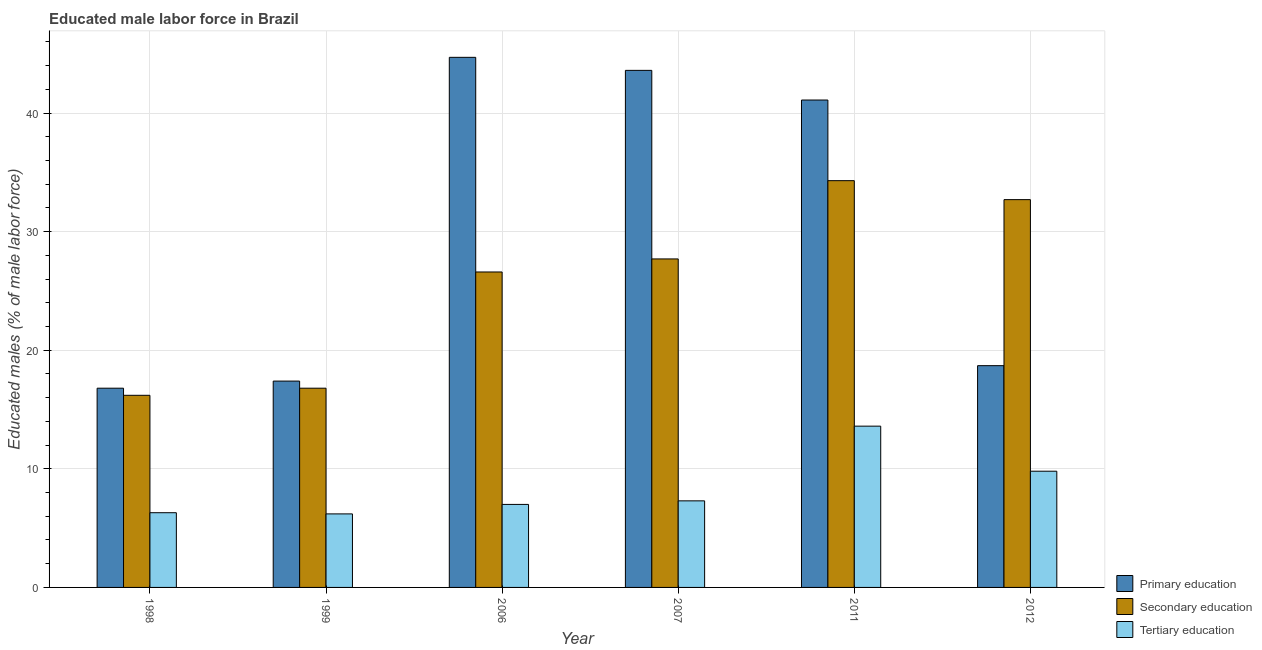How many groups of bars are there?
Your answer should be very brief. 6. How many bars are there on the 2nd tick from the left?
Keep it short and to the point. 3. In how many cases, is the number of bars for a given year not equal to the number of legend labels?
Your answer should be very brief. 0. What is the percentage of male labor force who received primary education in 2007?
Provide a succinct answer. 43.6. Across all years, what is the maximum percentage of male labor force who received tertiary education?
Offer a very short reply. 13.6. Across all years, what is the minimum percentage of male labor force who received tertiary education?
Ensure brevity in your answer.  6.2. What is the total percentage of male labor force who received tertiary education in the graph?
Offer a very short reply. 50.2. What is the difference between the percentage of male labor force who received primary education in 2006 and that in 2007?
Your response must be concise. 1.1. What is the difference between the percentage of male labor force who received tertiary education in 1999 and the percentage of male labor force who received secondary education in 2011?
Provide a succinct answer. -7.4. What is the average percentage of male labor force who received primary education per year?
Make the answer very short. 30.38. In the year 2007, what is the difference between the percentage of male labor force who received primary education and percentage of male labor force who received tertiary education?
Ensure brevity in your answer.  0. What is the ratio of the percentage of male labor force who received primary education in 2011 to that in 2012?
Keep it short and to the point. 2.2. What is the difference between the highest and the second highest percentage of male labor force who received secondary education?
Your response must be concise. 1.6. What is the difference between the highest and the lowest percentage of male labor force who received primary education?
Provide a succinct answer. 27.9. Is the sum of the percentage of male labor force who received primary education in 2011 and 2012 greater than the maximum percentage of male labor force who received tertiary education across all years?
Your answer should be very brief. Yes. What does the 1st bar from the right in 2006 represents?
Ensure brevity in your answer.  Tertiary education. Is it the case that in every year, the sum of the percentage of male labor force who received primary education and percentage of male labor force who received secondary education is greater than the percentage of male labor force who received tertiary education?
Offer a terse response. Yes. How many bars are there?
Offer a very short reply. 18. How many years are there in the graph?
Ensure brevity in your answer.  6. Are the values on the major ticks of Y-axis written in scientific E-notation?
Your answer should be compact. No. Does the graph contain any zero values?
Provide a succinct answer. No. Does the graph contain grids?
Give a very brief answer. Yes. Where does the legend appear in the graph?
Give a very brief answer. Bottom right. How many legend labels are there?
Keep it short and to the point. 3. How are the legend labels stacked?
Offer a very short reply. Vertical. What is the title of the graph?
Your answer should be very brief. Educated male labor force in Brazil. Does "Ages 60+" appear as one of the legend labels in the graph?
Ensure brevity in your answer.  No. What is the label or title of the Y-axis?
Keep it short and to the point. Educated males (% of male labor force). What is the Educated males (% of male labor force) in Primary education in 1998?
Ensure brevity in your answer.  16.8. What is the Educated males (% of male labor force) in Secondary education in 1998?
Give a very brief answer. 16.2. What is the Educated males (% of male labor force) of Tertiary education in 1998?
Your response must be concise. 6.3. What is the Educated males (% of male labor force) in Primary education in 1999?
Give a very brief answer. 17.4. What is the Educated males (% of male labor force) of Secondary education in 1999?
Give a very brief answer. 16.8. What is the Educated males (% of male labor force) of Tertiary education in 1999?
Provide a succinct answer. 6.2. What is the Educated males (% of male labor force) in Primary education in 2006?
Ensure brevity in your answer.  44.7. What is the Educated males (% of male labor force) of Secondary education in 2006?
Give a very brief answer. 26.6. What is the Educated males (% of male labor force) of Tertiary education in 2006?
Ensure brevity in your answer.  7. What is the Educated males (% of male labor force) of Primary education in 2007?
Your answer should be very brief. 43.6. What is the Educated males (% of male labor force) of Secondary education in 2007?
Ensure brevity in your answer.  27.7. What is the Educated males (% of male labor force) of Tertiary education in 2007?
Your answer should be very brief. 7.3. What is the Educated males (% of male labor force) in Primary education in 2011?
Your answer should be compact. 41.1. What is the Educated males (% of male labor force) in Secondary education in 2011?
Offer a very short reply. 34.3. What is the Educated males (% of male labor force) in Tertiary education in 2011?
Ensure brevity in your answer.  13.6. What is the Educated males (% of male labor force) in Primary education in 2012?
Ensure brevity in your answer.  18.7. What is the Educated males (% of male labor force) of Secondary education in 2012?
Ensure brevity in your answer.  32.7. What is the Educated males (% of male labor force) of Tertiary education in 2012?
Give a very brief answer. 9.8. Across all years, what is the maximum Educated males (% of male labor force) in Primary education?
Provide a succinct answer. 44.7. Across all years, what is the maximum Educated males (% of male labor force) of Secondary education?
Give a very brief answer. 34.3. Across all years, what is the maximum Educated males (% of male labor force) of Tertiary education?
Offer a terse response. 13.6. Across all years, what is the minimum Educated males (% of male labor force) in Primary education?
Offer a very short reply. 16.8. Across all years, what is the minimum Educated males (% of male labor force) in Secondary education?
Offer a very short reply. 16.2. Across all years, what is the minimum Educated males (% of male labor force) in Tertiary education?
Provide a short and direct response. 6.2. What is the total Educated males (% of male labor force) in Primary education in the graph?
Ensure brevity in your answer.  182.3. What is the total Educated males (% of male labor force) of Secondary education in the graph?
Ensure brevity in your answer.  154.3. What is the total Educated males (% of male labor force) of Tertiary education in the graph?
Offer a terse response. 50.2. What is the difference between the Educated males (% of male labor force) of Tertiary education in 1998 and that in 1999?
Provide a short and direct response. 0.1. What is the difference between the Educated males (% of male labor force) of Primary education in 1998 and that in 2006?
Keep it short and to the point. -27.9. What is the difference between the Educated males (% of male labor force) of Secondary education in 1998 and that in 2006?
Offer a very short reply. -10.4. What is the difference between the Educated males (% of male labor force) in Tertiary education in 1998 and that in 2006?
Your answer should be compact. -0.7. What is the difference between the Educated males (% of male labor force) of Primary education in 1998 and that in 2007?
Your answer should be very brief. -26.8. What is the difference between the Educated males (% of male labor force) in Primary education in 1998 and that in 2011?
Your response must be concise. -24.3. What is the difference between the Educated males (% of male labor force) of Secondary education in 1998 and that in 2011?
Make the answer very short. -18.1. What is the difference between the Educated males (% of male labor force) in Secondary education in 1998 and that in 2012?
Offer a terse response. -16.5. What is the difference between the Educated males (% of male labor force) in Tertiary education in 1998 and that in 2012?
Keep it short and to the point. -3.5. What is the difference between the Educated males (% of male labor force) in Primary education in 1999 and that in 2006?
Offer a very short reply. -27.3. What is the difference between the Educated males (% of male labor force) of Secondary education in 1999 and that in 2006?
Your response must be concise. -9.8. What is the difference between the Educated males (% of male labor force) of Tertiary education in 1999 and that in 2006?
Make the answer very short. -0.8. What is the difference between the Educated males (% of male labor force) in Primary education in 1999 and that in 2007?
Your answer should be compact. -26.2. What is the difference between the Educated males (% of male labor force) in Secondary education in 1999 and that in 2007?
Ensure brevity in your answer.  -10.9. What is the difference between the Educated males (% of male labor force) in Primary education in 1999 and that in 2011?
Your answer should be very brief. -23.7. What is the difference between the Educated males (% of male labor force) of Secondary education in 1999 and that in 2011?
Ensure brevity in your answer.  -17.5. What is the difference between the Educated males (% of male labor force) of Secondary education in 1999 and that in 2012?
Provide a short and direct response. -15.9. What is the difference between the Educated males (% of male labor force) of Tertiary education in 1999 and that in 2012?
Provide a succinct answer. -3.6. What is the difference between the Educated males (% of male labor force) in Primary education in 2006 and that in 2007?
Offer a very short reply. 1.1. What is the difference between the Educated males (% of male labor force) of Primary education in 2006 and that in 2011?
Your response must be concise. 3.6. What is the difference between the Educated males (% of male labor force) in Secondary education in 2006 and that in 2011?
Your answer should be compact. -7.7. What is the difference between the Educated males (% of male labor force) in Secondary education in 2007 and that in 2011?
Provide a short and direct response. -6.6. What is the difference between the Educated males (% of male labor force) of Tertiary education in 2007 and that in 2011?
Give a very brief answer. -6.3. What is the difference between the Educated males (% of male labor force) of Primary education in 2007 and that in 2012?
Ensure brevity in your answer.  24.9. What is the difference between the Educated males (% of male labor force) in Tertiary education in 2007 and that in 2012?
Your answer should be compact. -2.5. What is the difference between the Educated males (% of male labor force) in Primary education in 2011 and that in 2012?
Provide a short and direct response. 22.4. What is the difference between the Educated males (% of male labor force) in Tertiary education in 2011 and that in 2012?
Provide a short and direct response. 3.8. What is the difference between the Educated males (% of male labor force) of Primary education in 1998 and the Educated males (% of male labor force) of Secondary education in 1999?
Give a very brief answer. 0. What is the difference between the Educated males (% of male labor force) of Primary education in 1998 and the Educated males (% of male labor force) of Tertiary education in 1999?
Provide a succinct answer. 10.6. What is the difference between the Educated males (% of male labor force) in Primary education in 1998 and the Educated males (% of male labor force) in Tertiary education in 2006?
Offer a terse response. 9.8. What is the difference between the Educated males (% of male labor force) of Primary education in 1998 and the Educated males (% of male labor force) of Secondary education in 2007?
Offer a very short reply. -10.9. What is the difference between the Educated males (% of male labor force) of Primary education in 1998 and the Educated males (% of male labor force) of Tertiary education in 2007?
Keep it short and to the point. 9.5. What is the difference between the Educated males (% of male labor force) in Primary education in 1998 and the Educated males (% of male labor force) in Secondary education in 2011?
Offer a terse response. -17.5. What is the difference between the Educated males (% of male labor force) in Primary education in 1998 and the Educated males (% of male labor force) in Tertiary education in 2011?
Provide a short and direct response. 3.2. What is the difference between the Educated males (% of male labor force) in Primary education in 1998 and the Educated males (% of male labor force) in Secondary education in 2012?
Make the answer very short. -15.9. What is the difference between the Educated males (% of male labor force) of Primary education in 1998 and the Educated males (% of male labor force) of Tertiary education in 2012?
Ensure brevity in your answer.  7. What is the difference between the Educated males (% of male labor force) of Secondary education in 1998 and the Educated males (% of male labor force) of Tertiary education in 2012?
Ensure brevity in your answer.  6.4. What is the difference between the Educated males (% of male labor force) of Primary education in 1999 and the Educated males (% of male labor force) of Secondary education in 2006?
Keep it short and to the point. -9.2. What is the difference between the Educated males (% of male labor force) of Primary education in 1999 and the Educated males (% of male labor force) of Tertiary education in 2006?
Provide a succinct answer. 10.4. What is the difference between the Educated males (% of male labor force) of Secondary education in 1999 and the Educated males (% of male labor force) of Tertiary education in 2006?
Make the answer very short. 9.8. What is the difference between the Educated males (% of male labor force) in Primary education in 1999 and the Educated males (% of male labor force) in Tertiary education in 2007?
Your response must be concise. 10.1. What is the difference between the Educated males (% of male labor force) in Secondary education in 1999 and the Educated males (% of male labor force) in Tertiary education in 2007?
Give a very brief answer. 9.5. What is the difference between the Educated males (% of male labor force) in Primary education in 1999 and the Educated males (% of male labor force) in Secondary education in 2011?
Provide a short and direct response. -16.9. What is the difference between the Educated males (% of male labor force) in Primary education in 1999 and the Educated males (% of male labor force) in Tertiary education in 2011?
Offer a very short reply. 3.8. What is the difference between the Educated males (% of male labor force) in Primary education in 1999 and the Educated males (% of male labor force) in Secondary education in 2012?
Provide a succinct answer. -15.3. What is the difference between the Educated males (% of male labor force) in Secondary education in 1999 and the Educated males (% of male labor force) in Tertiary education in 2012?
Offer a very short reply. 7. What is the difference between the Educated males (% of male labor force) of Primary education in 2006 and the Educated males (% of male labor force) of Tertiary education in 2007?
Offer a terse response. 37.4. What is the difference between the Educated males (% of male labor force) of Secondary education in 2006 and the Educated males (% of male labor force) of Tertiary education in 2007?
Your answer should be compact. 19.3. What is the difference between the Educated males (% of male labor force) of Primary education in 2006 and the Educated males (% of male labor force) of Secondary education in 2011?
Ensure brevity in your answer.  10.4. What is the difference between the Educated males (% of male labor force) in Primary education in 2006 and the Educated males (% of male labor force) in Tertiary education in 2011?
Make the answer very short. 31.1. What is the difference between the Educated males (% of male labor force) of Secondary education in 2006 and the Educated males (% of male labor force) of Tertiary education in 2011?
Make the answer very short. 13. What is the difference between the Educated males (% of male labor force) in Primary education in 2006 and the Educated males (% of male labor force) in Secondary education in 2012?
Provide a succinct answer. 12. What is the difference between the Educated males (% of male labor force) of Primary education in 2006 and the Educated males (% of male labor force) of Tertiary education in 2012?
Your answer should be very brief. 34.9. What is the difference between the Educated males (% of male labor force) in Secondary education in 2006 and the Educated males (% of male labor force) in Tertiary education in 2012?
Provide a succinct answer. 16.8. What is the difference between the Educated males (% of male labor force) of Secondary education in 2007 and the Educated males (% of male labor force) of Tertiary education in 2011?
Offer a very short reply. 14.1. What is the difference between the Educated males (% of male labor force) of Primary education in 2007 and the Educated males (% of male labor force) of Secondary education in 2012?
Your response must be concise. 10.9. What is the difference between the Educated males (% of male labor force) of Primary education in 2007 and the Educated males (% of male labor force) of Tertiary education in 2012?
Your answer should be very brief. 33.8. What is the difference between the Educated males (% of male labor force) of Primary education in 2011 and the Educated males (% of male labor force) of Tertiary education in 2012?
Offer a very short reply. 31.3. What is the average Educated males (% of male labor force) in Primary education per year?
Your response must be concise. 30.38. What is the average Educated males (% of male labor force) in Secondary education per year?
Your response must be concise. 25.72. What is the average Educated males (% of male labor force) in Tertiary education per year?
Keep it short and to the point. 8.37. In the year 1999, what is the difference between the Educated males (% of male labor force) of Primary education and Educated males (% of male labor force) of Tertiary education?
Make the answer very short. 11.2. In the year 2006, what is the difference between the Educated males (% of male labor force) in Primary education and Educated males (% of male labor force) in Tertiary education?
Make the answer very short. 37.7. In the year 2006, what is the difference between the Educated males (% of male labor force) of Secondary education and Educated males (% of male labor force) of Tertiary education?
Provide a succinct answer. 19.6. In the year 2007, what is the difference between the Educated males (% of male labor force) in Primary education and Educated males (% of male labor force) in Tertiary education?
Give a very brief answer. 36.3. In the year 2007, what is the difference between the Educated males (% of male labor force) of Secondary education and Educated males (% of male labor force) of Tertiary education?
Your response must be concise. 20.4. In the year 2011, what is the difference between the Educated males (% of male labor force) of Secondary education and Educated males (% of male labor force) of Tertiary education?
Give a very brief answer. 20.7. In the year 2012, what is the difference between the Educated males (% of male labor force) in Primary education and Educated males (% of male labor force) in Secondary education?
Ensure brevity in your answer.  -14. In the year 2012, what is the difference between the Educated males (% of male labor force) of Secondary education and Educated males (% of male labor force) of Tertiary education?
Provide a succinct answer. 22.9. What is the ratio of the Educated males (% of male labor force) in Primary education in 1998 to that in 1999?
Your response must be concise. 0.97. What is the ratio of the Educated males (% of male labor force) in Secondary education in 1998 to that in 1999?
Provide a short and direct response. 0.96. What is the ratio of the Educated males (% of male labor force) in Tertiary education in 1998 to that in 1999?
Keep it short and to the point. 1.02. What is the ratio of the Educated males (% of male labor force) of Primary education in 1998 to that in 2006?
Give a very brief answer. 0.38. What is the ratio of the Educated males (% of male labor force) in Secondary education in 1998 to that in 2006?
Offer a very short reply. 0.61. What is the ratio of the Educated males (% of male labor force) in Tertiary education in 1998 to that in 2006?
Provide a short and direct response. 0.9. What is the ratio of the Educated males (% of male labor force) in Primary education in 1998 to that in 2007?
Offer a very short reply. 0.39. What is the ratio of the Educated males (% of male labor force) of Secondary education in 1998 to that in 2007?
Give a very brief answer. 0.58. What is the ratio of the Educated males (% of male labor force) in Tertiary education in 1998 to that in 2007?
Provide a short and direct response. 0.86. What is the ratio of the Educated males (% of male labor force) of Primary education in 1998 to that in 2011?
Ensure brevity in your answer.  0.41. What is the ratio of the Educated males (% of male labor force) of Secondary education in 1998 to that in 2011?
Make the answer very short. 0.47. What is the ratio of the Educated males (% of male labor force) in Tertiary education in 1998 to that in 2011?
Your answer should be very brief. 0.46. What is the ratio of the Educated males (% of male labor force) in Primary education in 1998 to that in 2012?
Offer a very short reply. 0.9. What is the ratio of the Educated males (% of male labor force) in Secondary education in 1998 to that in 2012?
Make the answer very short. 0.5. What is the ratio of the Educated males (% of male labor force) in Tertiary education in 1998 to that in 2012?
Offer a terse response. 0.64. What is the ratio of the Educated males (% of male labor force) of Primary education in 1999 to that in 2006?
Provide a short and direct response. 0.39. What is the ratio of the Educated males (% of male labor force) in Secondary education in 1999 to that in 2006?
Your response must be concise. 0.63. What is the ratio of the Educated males (% of male labor force) in Tertiary education in 1999 to that in 2006?
Make the answer very short. 0.89. What is the ratio of the Educated males (% of male labor force) in Primary education in 1999 to that in 2007?
Offer a terse response. 0.4. What is the ratio of the Educated males (% of male labor force) of Secondary education in 1999 to that in 2007?
Keep it short and to the point. 0.61. What is the ratio of the Educated males (% of male labor force) of Tertiary education in 1999 to that in 2007?
Give a very brief answer. 0.85. What is the ratio of the Educated males (% of male labor force) of Primary education in 1999 to that in 2011?
Provide a short and direct response. 0.42. What is the ratio of the Educated males (% of male labor force) of Secondary education in 1999 to that in 2011?
Make the answer very short. 0.49. What is the ratio of the Educated males (% of male labor force) in Tertiary education in 1999 to that in 2011?
Your answer should be compact. 0.46. What is the ratio of the Educated males (% of male labor force) in Primary education in 1999 to that in 2012?
Ensure brevity in your answer.  0.93. What is the ratio of the Educated males (% of male labor force) in Secondary education in 1999 to that in 2012?
Provide a short and direct response. 0.51. What is the ratio of the Educated males (% of male labor force) of Tertiary education in 1999 to that in 2012?
Ensure brevity in your answer.  0.63. What is the ratio of the Educated males (% of male labor force) in Primary education in 2006 to that in 2007?
Provide a short and direct response. 1.03. What is the ratio of the Educated males (% of male labor force) in Secondary education in 2006 to that in 2007?
Offer a terse response. 0.96. What is the ratio of the Educated males (% of male labor force) in Tertiary education in 2006 to that in 2007?
Provide a succinct answer. 0.96. What is the ratio of the Educated males (% of male labor force) in Primary education in 2006 to that in 2011?
Make the answer very short. 1.09. What is the ratio of the Educated males (% of male labor force) in Secondary education in 2006 to that in 2011?
Provide a succinct answer. 0.78. What is the ratio of the Educated males (% of male labor force) in Tertiary education in 2006 to that in 2011?
Make the answer very short. 0.51. What is the ratio of the Educated males (% of male labor force) of Primary education in 2006 to that in 2012?
Offer a very short reply. 2.39. What is the ratio of the Educated males (% of male labor force) in Secondary education in 2006 to that in 2012?
Your response must be concise. 0.81. What is the ratio of the Educated males (% of male labor force) in Primary education in 2007 to that in 2011?
Provide a short and direct response. 1.06. What is the ratio of the Educated males (% of male labor force) of Secondary education in 2007 to that in 2011?
Keep it short and to the point. 0.81. What is the ratio of the Educated males (% of male labor force) in Tertiary education in 2007 to that in 2011?
Your response must be concise. 0.54. What is the ratio of the Educated males (% of male labor force) of Primary education in 2007 to that in 2012?
Your answer should be compact. 2.33. What is the ratio of the Educated males (% of male labor force) of Secondary education in 2007 to that in 2012?
Give a very brief answer. 0.85. What is the ratio of the Educated males (% of male labor force) in Tertiary education in 2007 to that in 2012?
Offer a very short reply. 0.74. What is the ratio of the Educated males (% of male labor force) of Primary education in 2011 to that in 2012?
Your answer should be very brief. 2.2. What is the ratio of the Educated males (% of male labor force) in Secondary education in 2011 to that in 2012?
Your answer should be very brief. 1.05. What is the ratio of the Educated males (% of male labor force) of Tertiary education in 2011 to that in 2012?
Make the answer very short. 1.39. What is the difference between the highest and the second highest Educated males (% of male labor force) in Primary education?
Your response must be concise. 1.1. What is the difference between the highest and the second highest Educated males (% of male labor force) in Secondary education?
Give a very brief answer. 1.6. What is the difference between the highest and the second highest Educated males (% of male labor force) of Tertiary education?
Provide a short and direct response. 3.8. What is the difference between the highest and the lowest Educated males (% of male labor force) of Primary education?
Give a very brief answer. 27.9. 